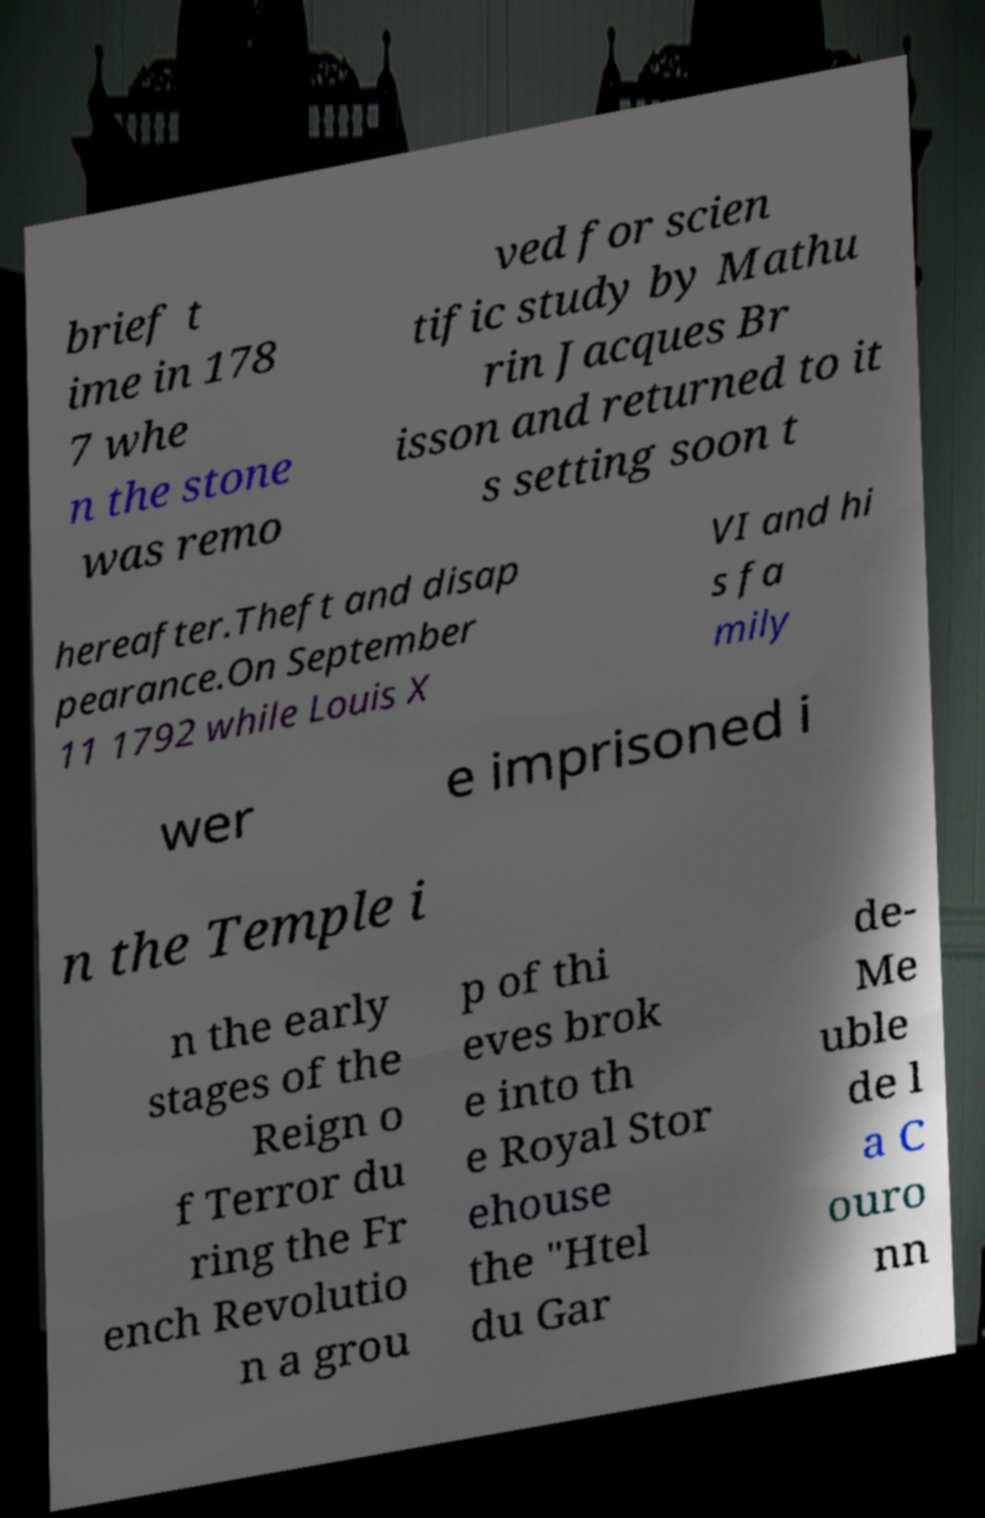Please identify and transcribe the text found in this image. brief t ime in 178 7 whe n the stone was remo ved for scien tific study by Mathu rin Jacques Br isson and returned to it s setting soon t hereafter.Theft and disap pearance.On September 11 1792 while Louis X VI and hi s fa mily wer e imprisoned i n the Temple i n the early stages of the Reign o f Terror du ring the Fr ench Revolutio n a grou p of thi eves brok e into th e Royal Stor ehouse the "Htel du Gar de- Me uble de l a C ouro nn 